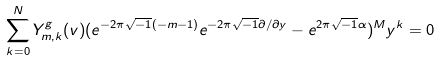<formula> <loc_0><loc_0><loc_500><loc_500>\sum _ { k = 0 } ^ { N } Y ^ { g } _ { m , k } ( v ) ( e ^ { - 2 \pi \sqrt { - 1 } ( - m - 1 ) } e ^ { - 2 \pi \sqrt { - 1 } \partial / \partial y } - e ^ { 2 \pi \sqrt { - 1 } \alpha } ) ^ { M } y ^ { k } = 0</formula> 